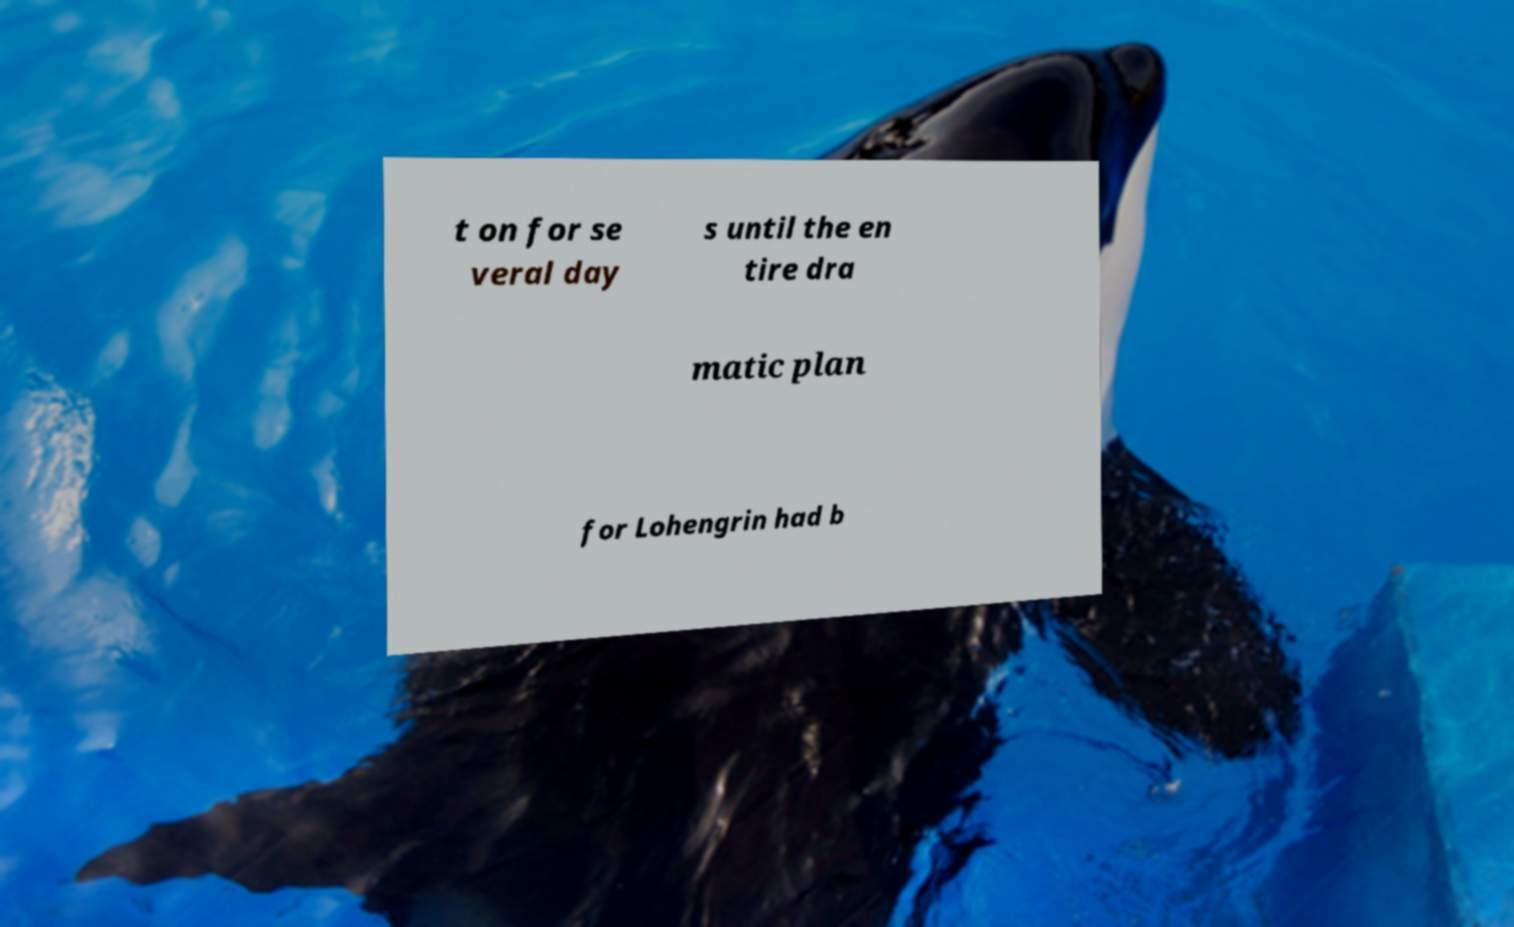Could you extract and type out the text from this image? t on for se veral day s until the en tire dra matic plan for Lohengrin had b 